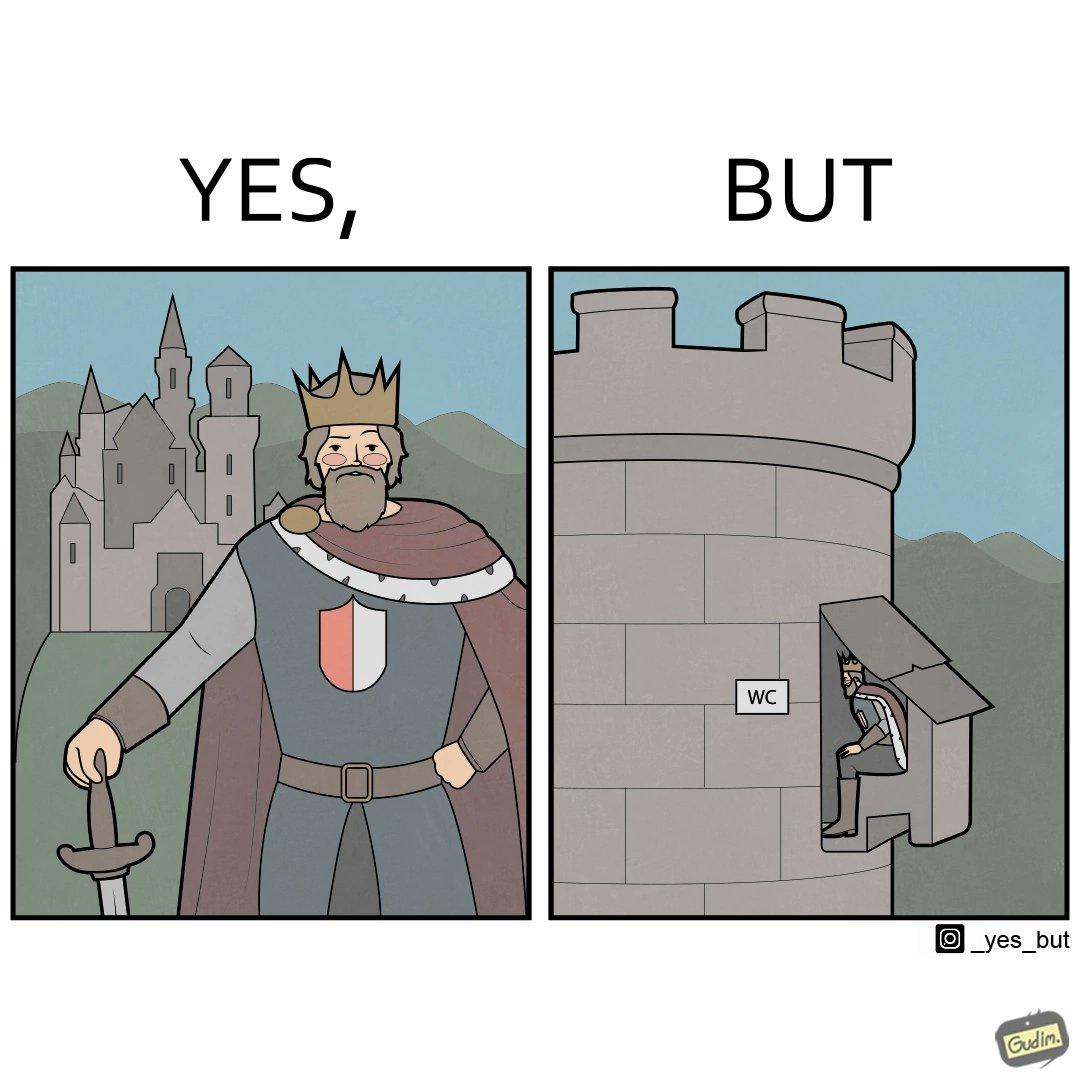What makes this image funny or satirical? The images are funny since it shows how even a mighty king must do simple things like using a toilet just like everyone else does 